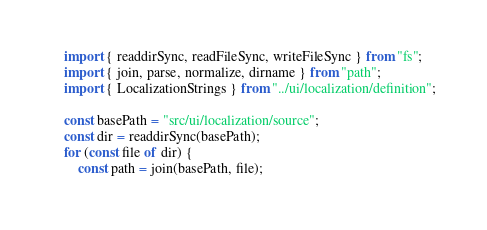Convert code to text. <code><loc_0><loc_0><loc_500><loc_500><_TypeScript_>import { readdirSync, readFileSync, writeFileSync } from "fs";
import { join, parse, normalize, dirname } from "path";
import { LocalizationStrings } from "../ui/localization/definition";

const basePath = "src/ui/localization/source";
const dir = readdirSync(basePath);
for (const file of dir) {
    const path = join(basePath, file);</code> 